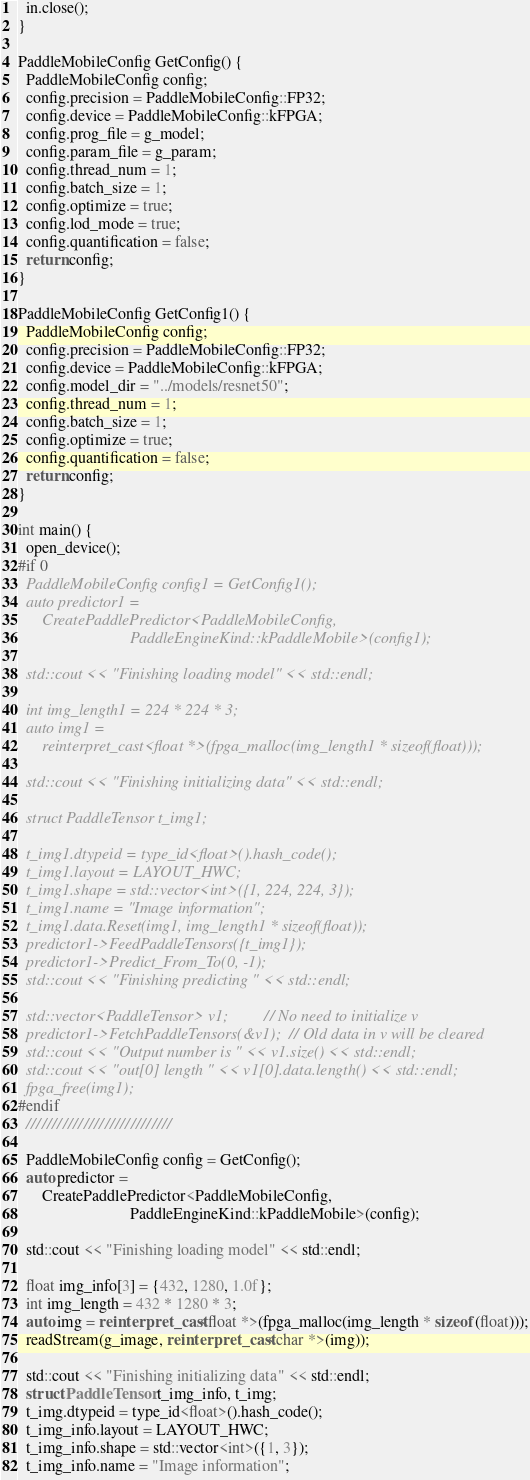<code> <loc_0><loc_0><loc_500><loc_500><_C++_>  in.close();
}

PaddleMobileConfig GetConfig() {
  PaddleMobileConfig config;
  config.precision = PaddleMobileConfig::FP32;
  config.device = PaddleMobileConfig::kFPGA;
  config.prog_file = g_model;
  config.param_file = g_param;
  config.thread_num = 1;
  config.batch_size = 1;
  config.optimize = true;
  config.lod_mode = true;
  config.quantification = false;
  return config;
}

PaddleMobileConfig GetConfig1() {
  PaddleMobileConfig config;
  config.precision = PaddleMobileConfig::FP32;
  config.device = PaddleMobileConfig::kFPGA;
  config.model_dir = "../models/resnet50";
  config.thread_num = 1;
  config.batch_size = 1;
  config.optimize = true;
  config.quantification = false;
  return config;
}

int main() {
  open_device();
#if 0
  PaddleMobileConfig config1 = GetConfig1();
  auto predictor1 =
      CreatePaddlePredictor<PaddleMobileConfig,
                            PaddleEngineKind::kPaddleMobile>(config1);

  std::cout << "Finishing loading model" << std::endl;

  int img_length1 = 224 * 224 * 3;
  auto img1 =
      reinterpret_cast<float *>(fpga_malloc(img_length1 * sizeof(float)));

  std::cout << "Finishing initializing data" << std::endl;

  struct PaddleTensor t_img1;

  t_img1.dtypeid = type_id<float>().hash_code();
  t_img1.layout = LAYOUT_HWC;
  t_img1.shape = std::vector<int>({1, 224, 224, 3});
  t_img1.name = "Image information";
  t_img1.data.Reset(img1, img_length1 * sizeof(float));
  predictor1->FeedPaddleTensors({t_img1});
  predictor1->Predict_From_To(0, -1);
  std::cout << "Finishing predicting " << std::endl;

  std::vector<PaddleTensor> v1;         // No need to initialize v
  predictor1->FetchPaddleTensors(&v1);  // Old data in v will be cleared
  std::cout << "Output number is " << v1.size() << std::endl;
  std::cout << "out[0] length " << v1[0].data.length() << std::endl;
  fpga_free(img1);
#endif
  ////////////////////////////

  PaddleMobileConfig config = GetConfig();
  auto predictor =
      CreatePaddlePredictor<PaddleMobileConfig,
                            PaddleEngineKind::kPaddleMobile>(config);

  std::cout << "Finishing loading model" << std::endl;

  float img_info[3] = {432, 1280, 1.0f};
  int img_length = 432 * 1280 * 3;
  auto img = reinterpret_cast<float *>(fpga_malloc(img_length * sizeof(float)));
  readStream(g_image, reinterpret_cast<char *>(img));

  std::cout << "Finishing initializing data" << std::endl;
  struct PaddleTensor t_img_info, t_img;
  t_img.dtypeid = type_id<float>().hash_code();
  t_img_info.layout = LAYOUT_HWC;
  t_img_info.shape = std::vector<int>({1, 3});
  t_img_info.name = "Image information";</code> 